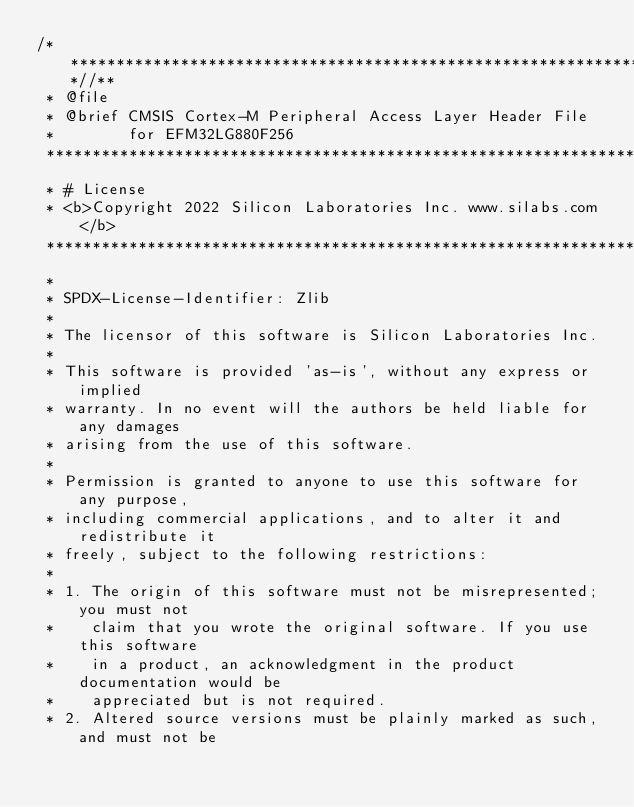<code> <loc_0><loc_0><loc_500><loc_500><_C_>/***************************************************************************//**
 * @file
 * @brief CMSIS Cortex-M Peripheral Access Layer Header File
 *        for EFM32LG880F256
 *******************************************************************************
 * # License
 * <b>Copyright 2022 Silicon Laboratories Inc. www.silabs.com</b>
 *******************************************************************************
 *
 * SPDX-License-Identifier: Zlib
 *
 * The licensor of this software is Silicon Laboratories Inc.
 *
 * This software is provided 'as-is', without any express or implied
 * warranty. In no event will the authors be held liable for any damages
 * arising from the use of this software.
 *
 * Permission is granted to anyone to use this software for any purpose,
 * including commercial applications, and to alter it and redistribute it
 * freely, subject to the following restrictions:
 *
 * 1. The origin of this software must not be misrepresented; you must not
 *    claim that you wrote the original software. If you use this software
 *    in a product, an acknowledgment in the product documentation would be
 *    appreciated but is not required.
 * 2. Altered source versions must be plainly marked as such, and must not be</code> 